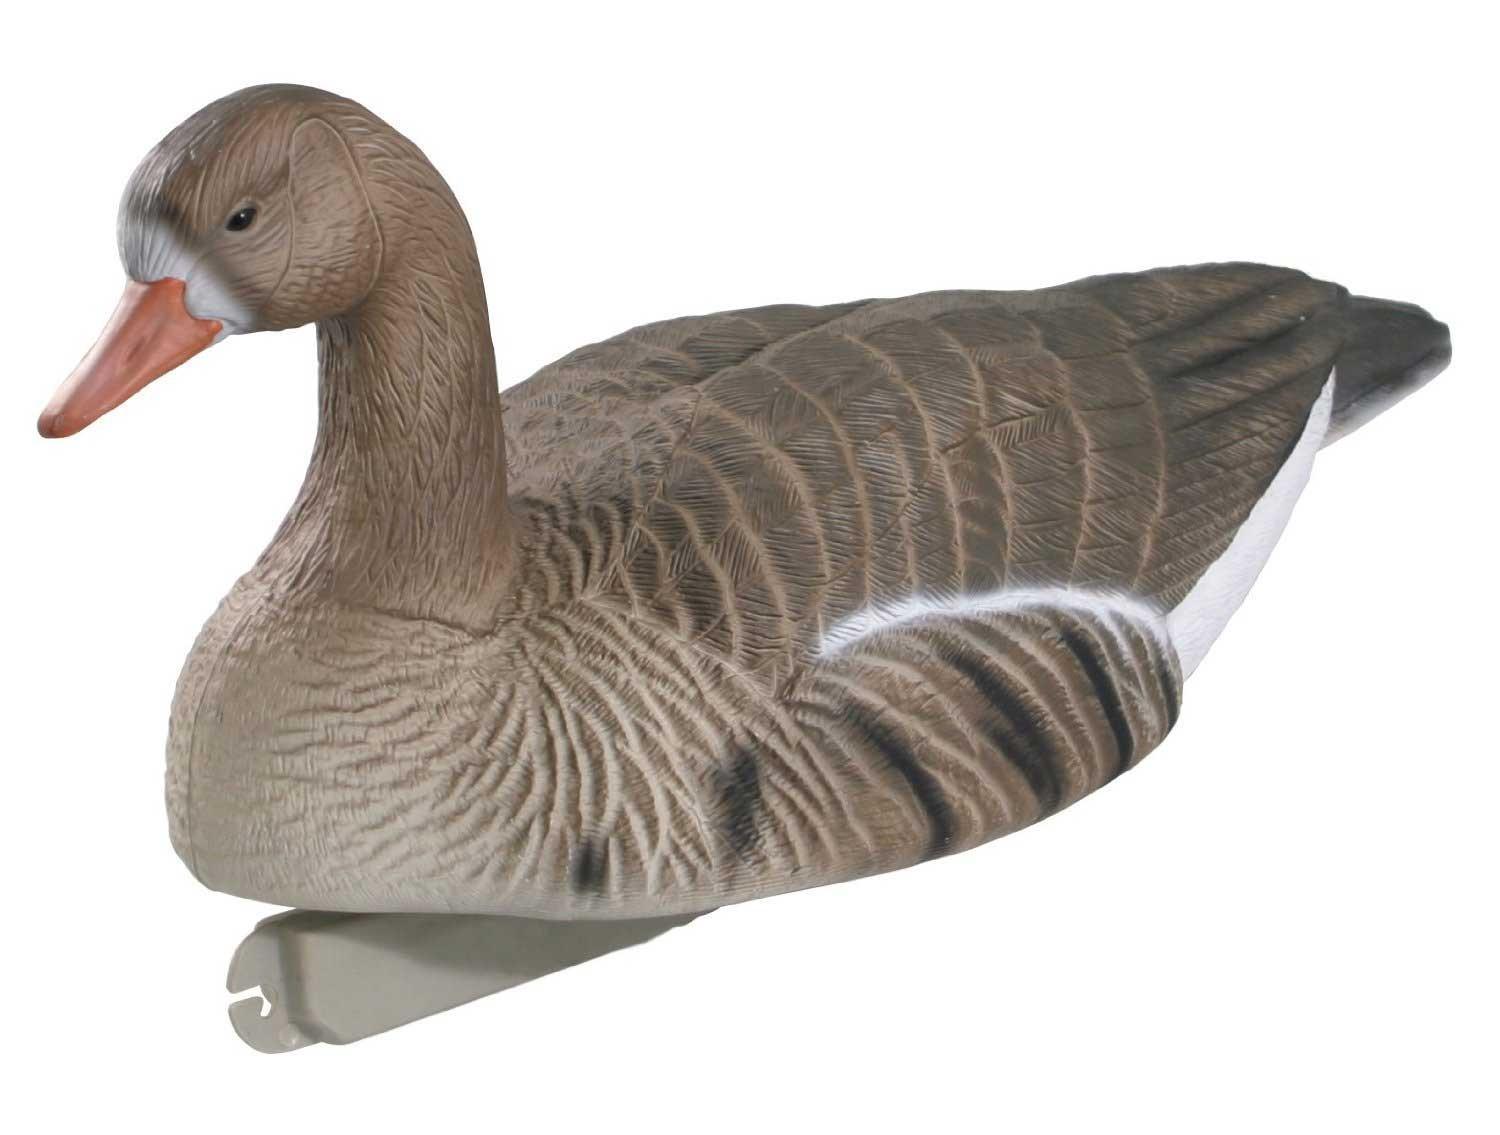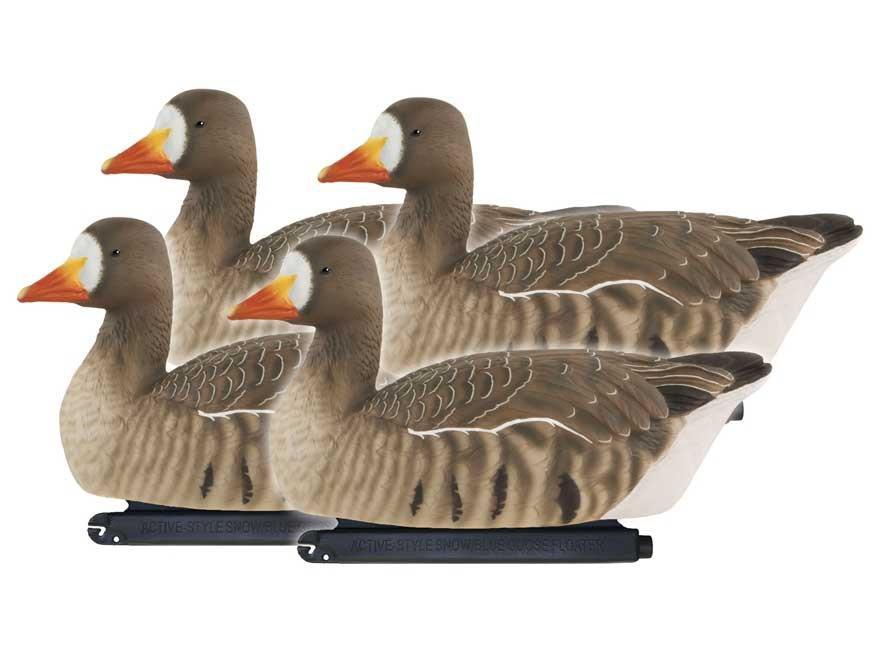The first image is the image on the left, the second image is the image on the right. Considering the images on both sides, is "There are five duck decoys." valid? Answer yes or no. Yes. The first image is the image on the left, the second image is the image on the right. Evaluate the accuracy of this statement regarding the images: "All decoy birds have black necks, and one image contains at least four decoy birds, while the other image contains just one.". Is it true? Answer yes or no. No. 